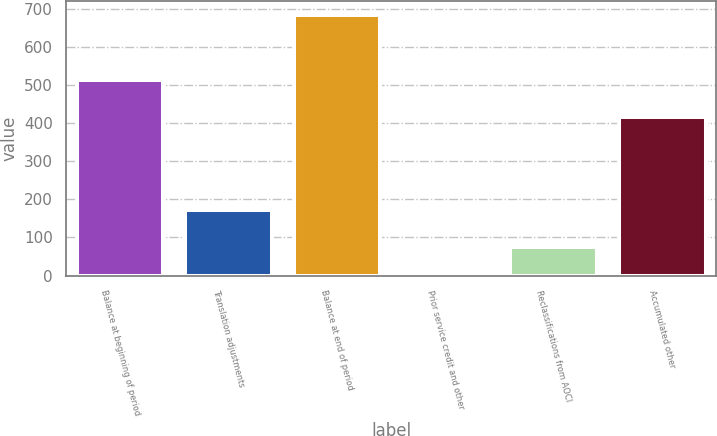Convert chart to OTSL. <chart><loc_0><loc_0><loc_500><loc_500><bar_chart><fcel>Balance at beginning of period<fcel>Translation adjustments<fcel>Balance at end of period<fcel>Prior service credit and other<fcel>Reclassifications from AOCI<fcel>Accumulated other<nl><fcel>514<fcel>171<fcel>685<fcel>1<fcel>76<fcel>415<nl></chart> 